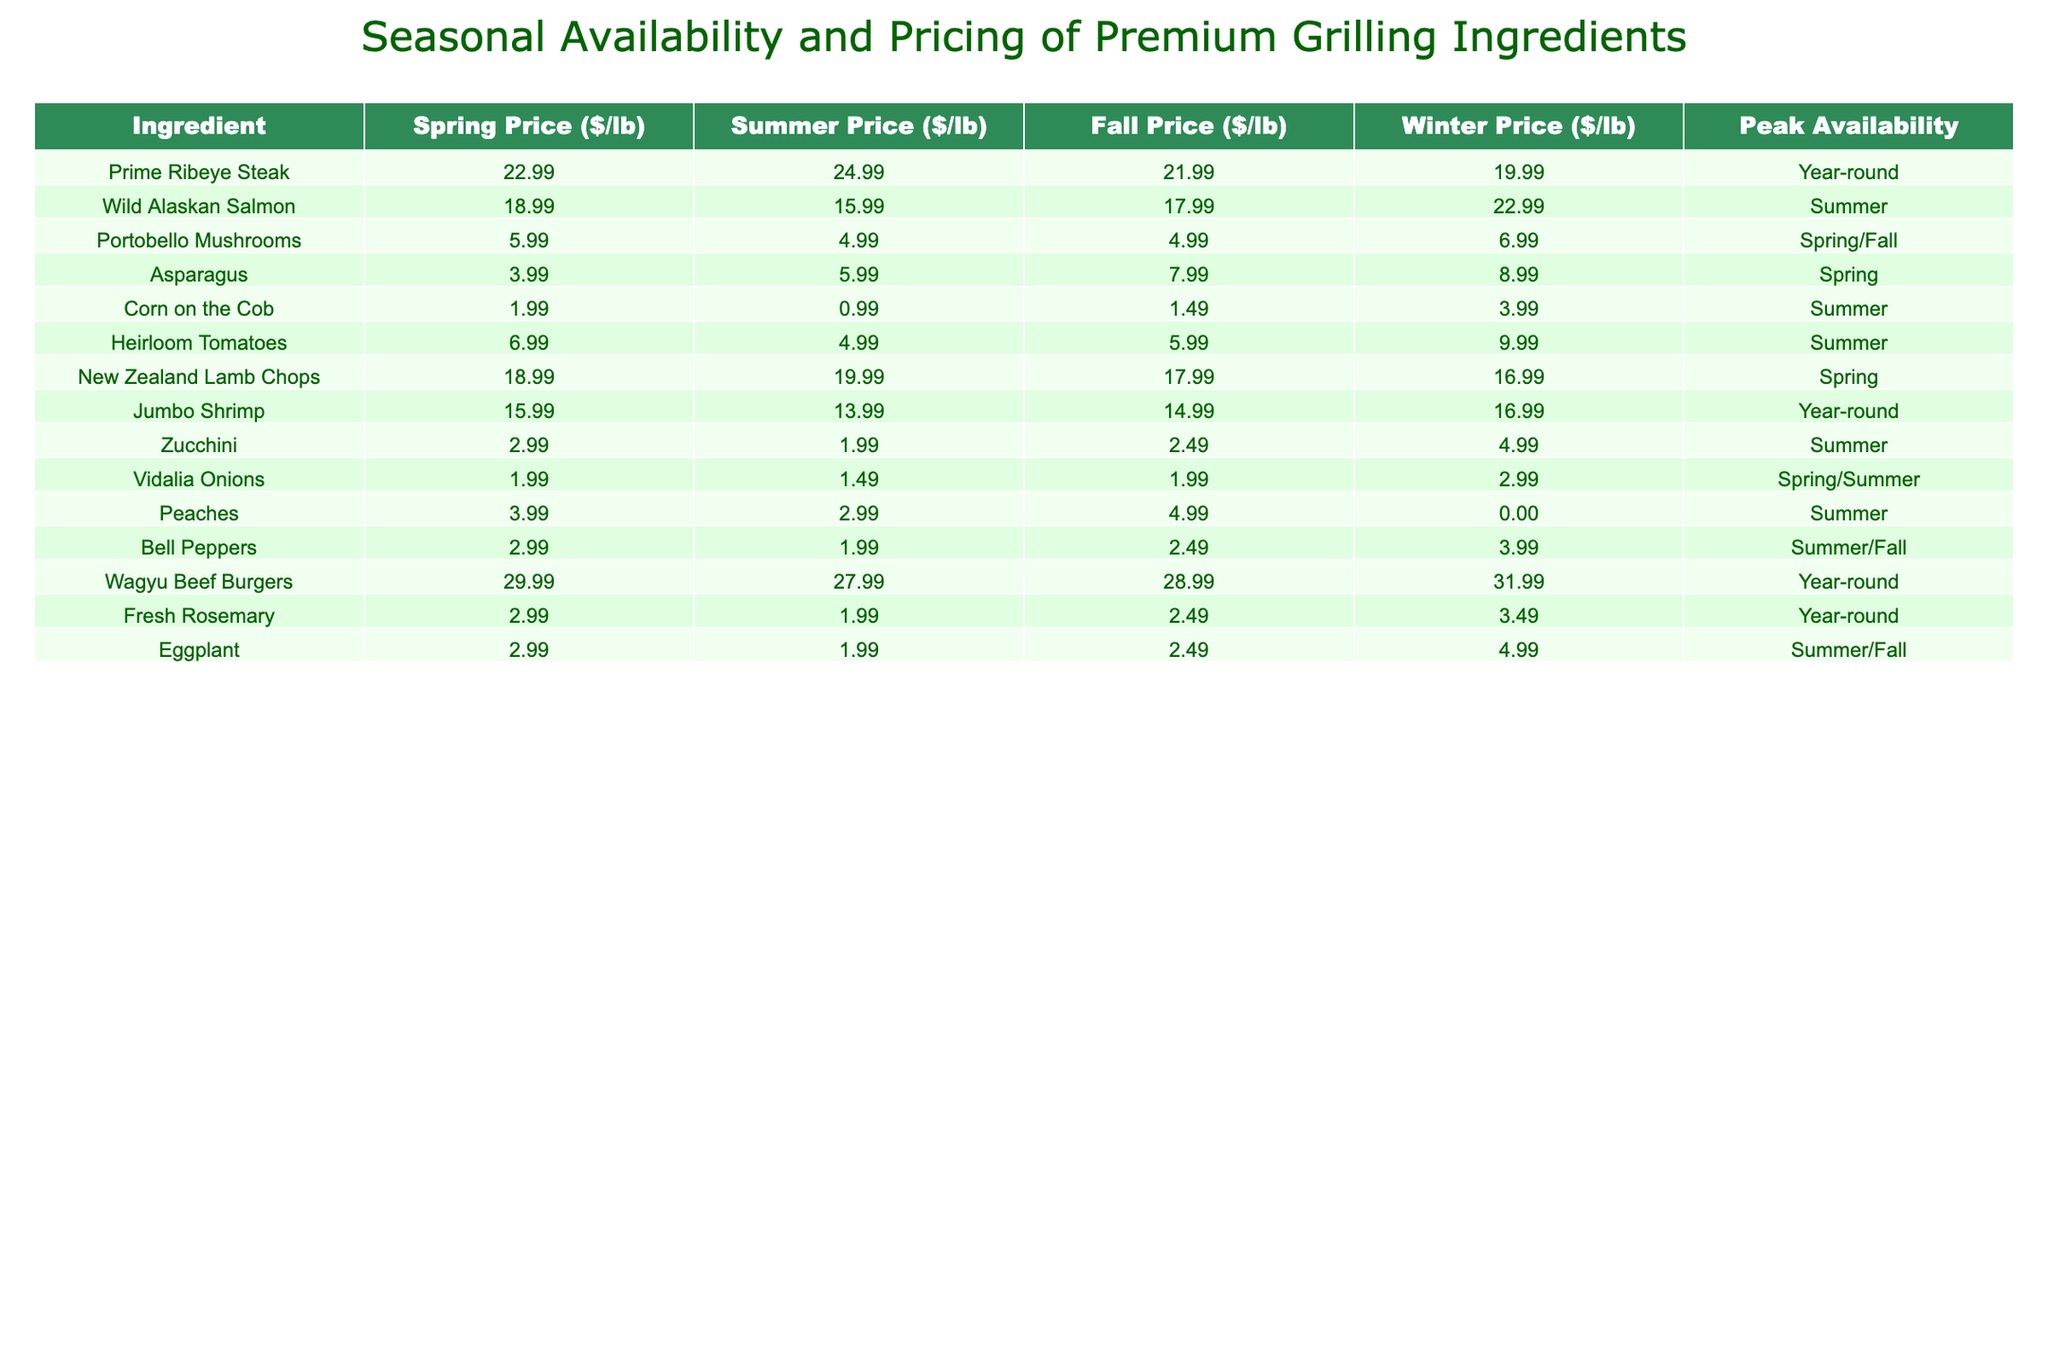What is the price per pound of Wild Alaskan Salmon in the summer? The table shows that the price of Wild Alaskan Salmon in the summer is $15.99 per pound.
Answer: $15.99 Which ingredient has the highest price in spring? Looking at the spring prices, Wagyu Beef Burgers are priced at $29.99 per pound, which is the highest among all ingredients.
Answer: Wagyu Beef Burgers Is Corn on the Cob more expensive in winter than in summer? Winter price for Corn on the Cob is $3.99, while the summer price is $0.99, making it cheaper in summer.
Answer: No What is the average price of New Zealand Lamb Chops throughout the year? The prices are $18.99 (Spring), $19.99 (Summer), $17.99 (Fall), and $16.99 (Winter). Adding these gives $73.96, and dividing by 4 results in an average of $18.49.
Answer: $18.49 Which ingredients are peak available in spring? The table indicates that Prime Ribeye Steak, Portobello Mushrooms, Asparagus, New Zealand Lamb Chops, and Vidalia Onions are all peak available in spring.
Answer: 5 ingredients In which season is Zucchini the least expensive? The table shows that Zucchini costs $1.99 per pound in summer, making it the least expensive during that season.
Answer: Summer What is the seasonal price difference for Heirloom Tomatoes between summer and fall? The price for Heirloom Tomatoes in summer is $4.99 and in fall is $5.99. The difference is $5.99 - $4.99 = $1.00.
Answer: $1.00 Are Portobello Mushrooms cheaper in fall than in spring? The price of Portobello Mushrooms in spring is $5.99 and in fall is $4.99, confirming they are indeed cheaper in fall.
Answer: Yes What is the total price for one pound of each ingredient in spring? Summing the spring prices gives $22.99 + $18.99 + $5.99 + $3.99 + $1.99 + $6.99 + $18.99 + $15.99 + $2.99 + $1.99 + $3.99 + $2.99 + $2.99 = $92.90.
Answer: $92.90 Which ingredient has the largest winter price among those listed? The table shows that Wagyu Beef Burgers cost $31.99 in winter, representing the highest price in that season.
Answer: Wagyu Beef Burgers 